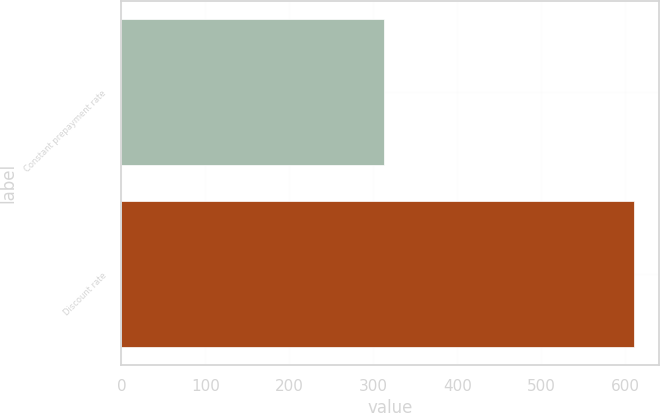Convert chart to OTSL. <chart><loc_0><loc_0><loc_500><loc_500><bar_chart><fcel>Constant prepayment rate<fcel>Discount rate<nl><fcel>313<fcel>610<nl></chart> 